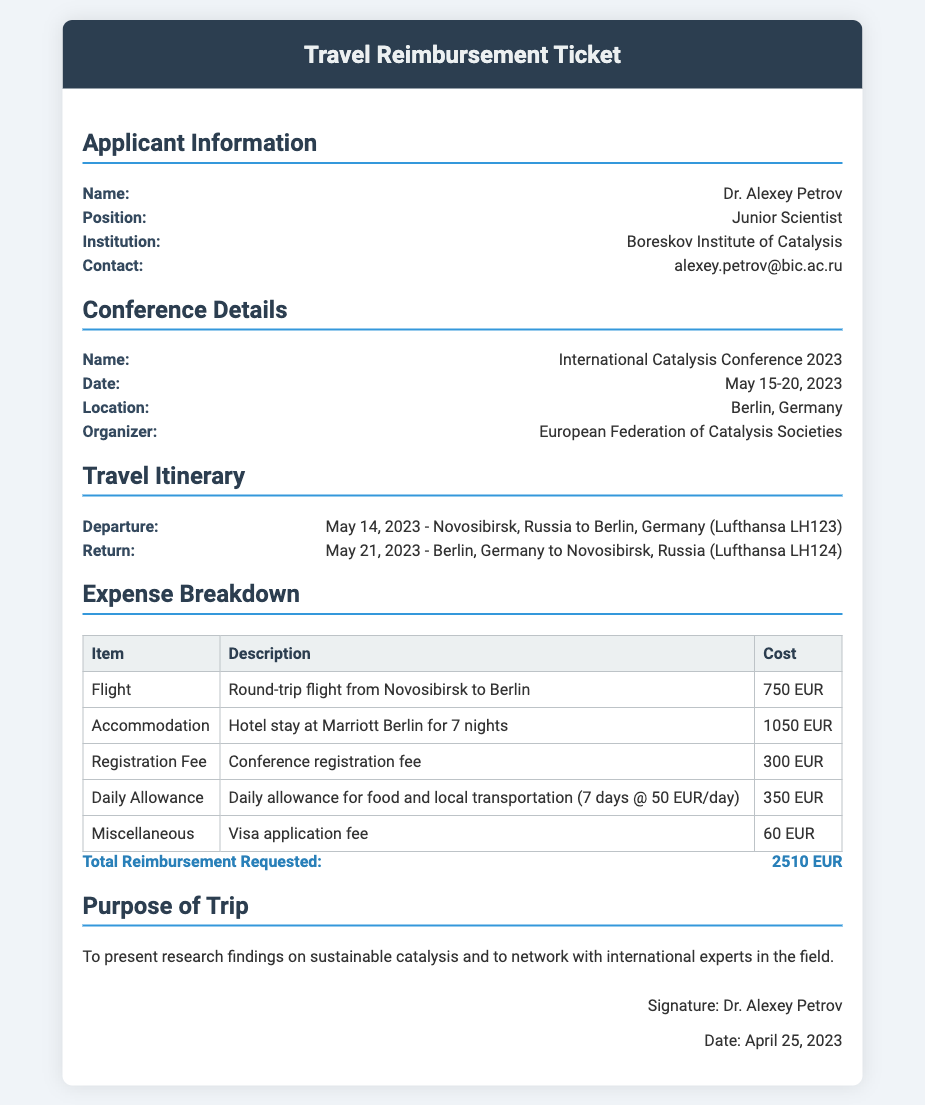What is the applicant's name? The document states the applicant's name is Dr. Alexey Petrov.
Answer: Dr. Alexey Petrov What is the total reimbursement requested? The total reimbursement requested is listed as 2510 EUR in the expense breakdown.
Answer: 2510 EUR What is the date of the conference? The conference date is provided as May 15-20, 2023.
Answer: May 15-20, 2023 What is the location of the conference? The document specifies that the location of the conference is Berlin, Germany.
Answer: Berlin, Germany How much was spent on accommodation? The accommodation cost for the hotel stay is listed as 1050 EUR.
Answer: 1050 EUR What is the purpose of the trip? The purpose of the trip stated in the document is to present research findings on sustainable catalysis and to network with international experts.
Answer: Present research findings on sustainable catalysis and to network with international experts What type of travel was undertaken? The travel type includes a round-trip flight from Novosibirsk to Berlin.
Answer: Round-trip flight Who organized the conference? The document states that the conference was organized by the European Federation of Catalysis Societies.
Answer: European Federation of Catalysis Societies What expense category includes the visa application fee? The expense breakdown lists the visa application fee under the Miscellaneous category.
Answer: Miscellaneous 